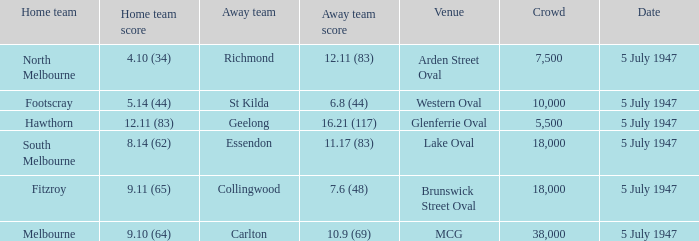8 (44)? Footscray. 